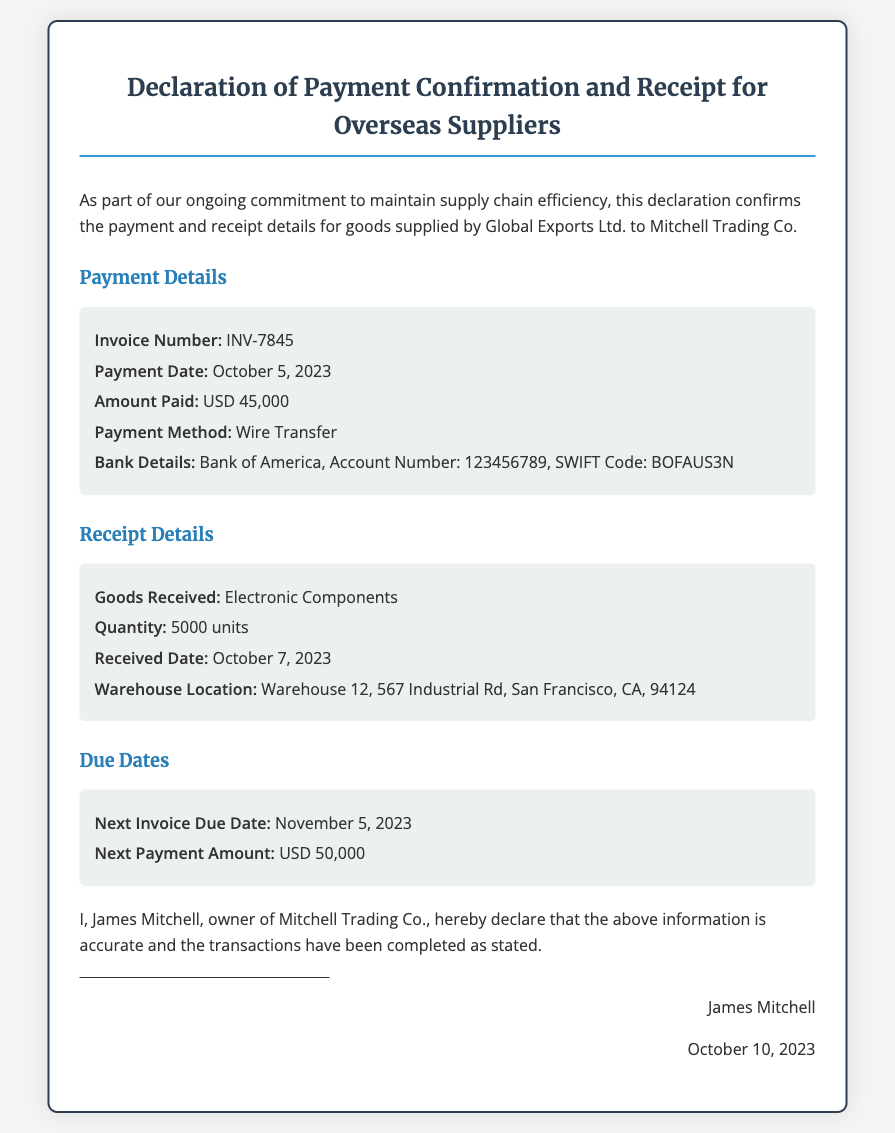What is the invoice number? The invoice number is explicitly stated under payment details in the document.
Answer: INV-7845 When was the payment made? The payment date is specified in the payment details section.
Answer: October 5, 2023 What is the amount paid? The document contains the payment amount in the payment details section.
Answer: USD 45,000 What goods were received? The type of goods received is mentioned in the receipt details section.
Answer: Electronic Components When is the next invoice due date? The next invoice due date is listed under the due dates section of the document.
Answer: November 5, 2023 Who is the owner of Mitchell Trading Co.? The declaration includes the name of the owner at the end of the document.
Answer: James Mitchell What was the payment method used? The payment method is outlined in the payment details section of the document.
Answer: Wire Transfer How many units were received? The quantity of goods received is provided in the receipt details section.
Answer: 5000 units 